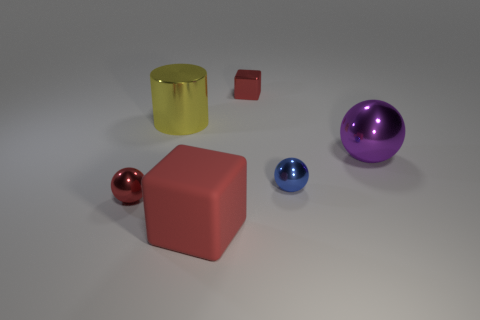Does the red shiny object that is behind the red shiny ball have the same shape as the large metal object left of the big purple object?
Provide a succinct answer. No. What number of blocks are either large matte things or yellow things?
Provide a short and direct response. 1. What is the material of the tiny red thing that is on the left side of the red metallic object on the right side of the large shiny object that is behind the purple object?
Offer a terse response. Metal. There is another shiny cube that is the same color as the big cube; what is its size?
Offer a terse response. Small. Are there more red matte blocks behind the rubber thing than red shiny spheres?
Make the answer very short. No. Is there a big object of the same color as the big cylinder?
Give a very brief answer. No. There is a cube that is the same size as the purple thing; what color is it?
Your response must be concise. Red. There is a metallic thing that is on the left side of the large metallic cylinder; what number of cubes are behind it?
Keep it short and to the point. 1. How many things are either red things to the left of the red rubber cube or tiny green shiny cylinders?
Offer a very short reply. 1. What number of purple objects are made of the same material as the big red cube?
Give a very brief answer. 0. 